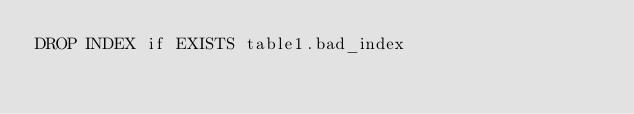<code> <loc_0><loc_0><loc_500><loc_500><_SQL_>DROP INDEX if EXISTS table1.bad_index</code> 